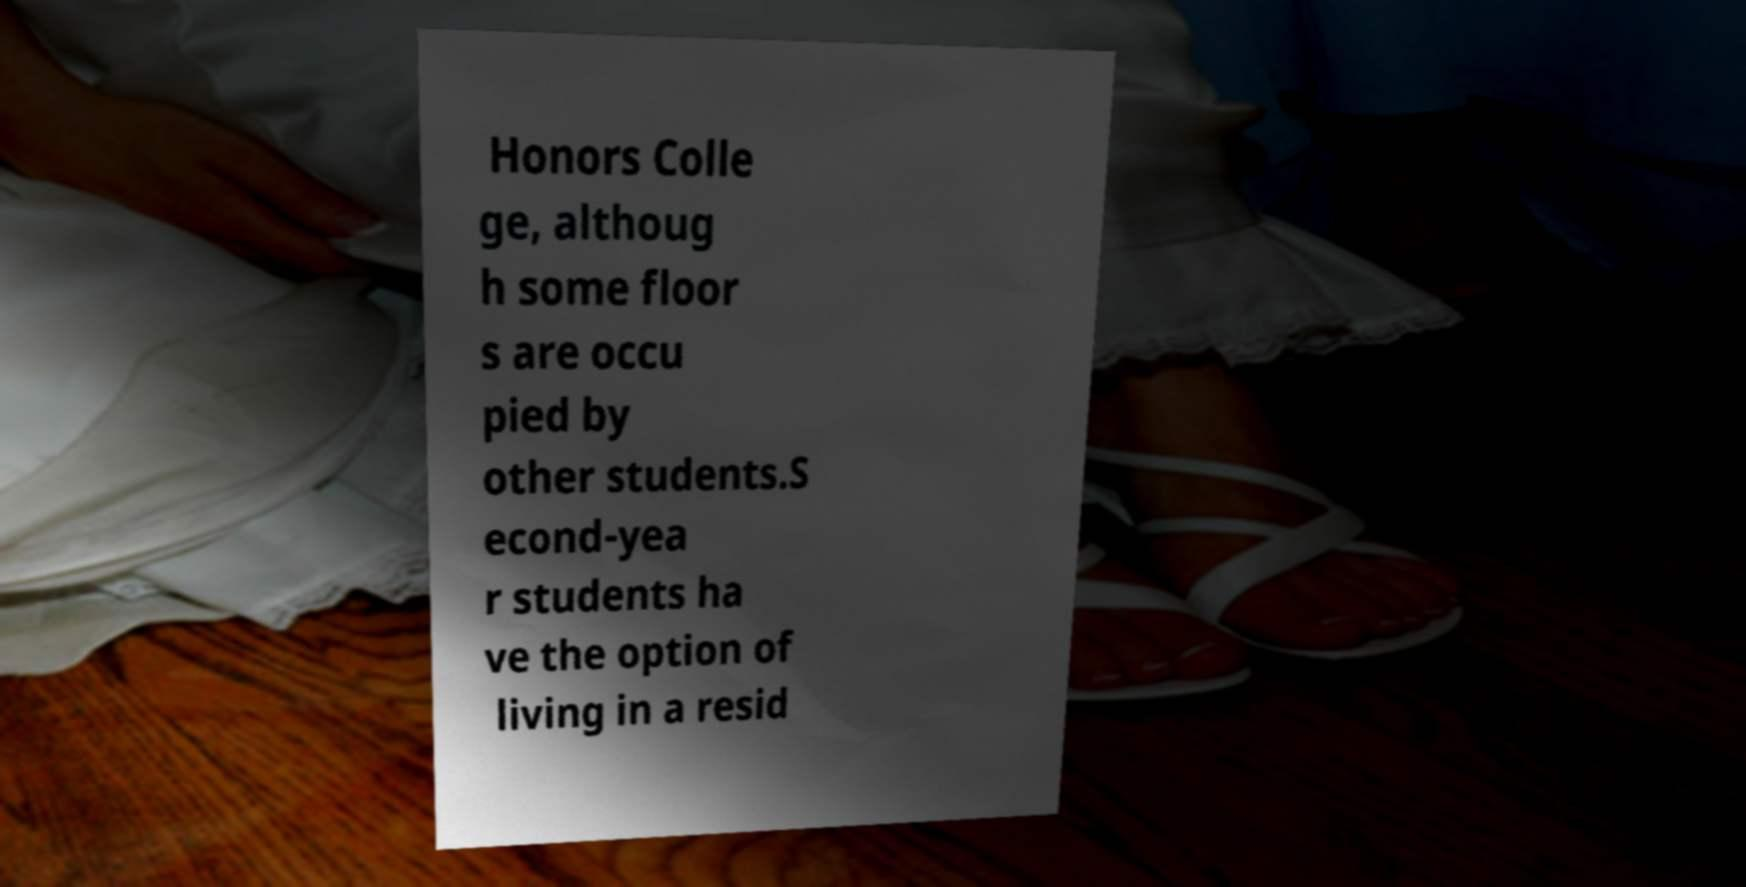Can you accurately transcribe the text from the provided image for me? Honors Colle ge, althoug h some floor s are occu pied by other students.S econd-yea r students ha ve the option of living in a resid 